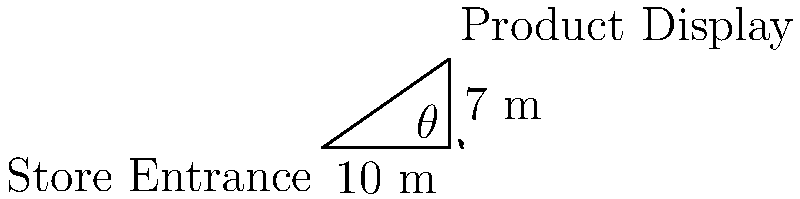As a marketing specialist, you're tasked with optimizing the placement of a new product display in a store. The display needs to be visible from the store entrance. The store layout is represented by a right-angled triangle, where the entrance is at point A, and the display will be placed at point C. If the distance from the entrance to the nearest wall is 10 meters, and the perpendicular distance from that wall to the display is 7 meters, at what angle $\theta$ (in degrees, rounded to the nearest whole number) should the display be positioned relative to the entrance for maximum visibility? To solve this problem, we'll use the tangent function from trigonometry. Here's the step-by-step solution:

1) In the right-angled triangle ABC:
   - The adjacent side (AB) is 10 meters
   - The opposite side (BC) is 7 meters
   - We need to find the angle $\theta$ at B

2) The tangent of an angle in a right-angled triangle is defined as:

   $\tan(\theta) = \frac{\text{opposite}}{\text{adjacent}}$

3) Substituting our values:

   $\tan(\theta) = \frac{7}{10}$

4) To find $\theta$, we need to use the inverse tangent (arctangent) function:

   $\theta = \arctan(\frac{7}{10})$

5) Using a calculator or computer:

   $\theta \approx 34.9920°$

6) Rounding to the nearest whole number:

   $\theta \approx 35°$

Therefore, for maximum visibility, the product display should be positioned at an angle of approximately 35° relative to the entrance.
Answer: 35° 